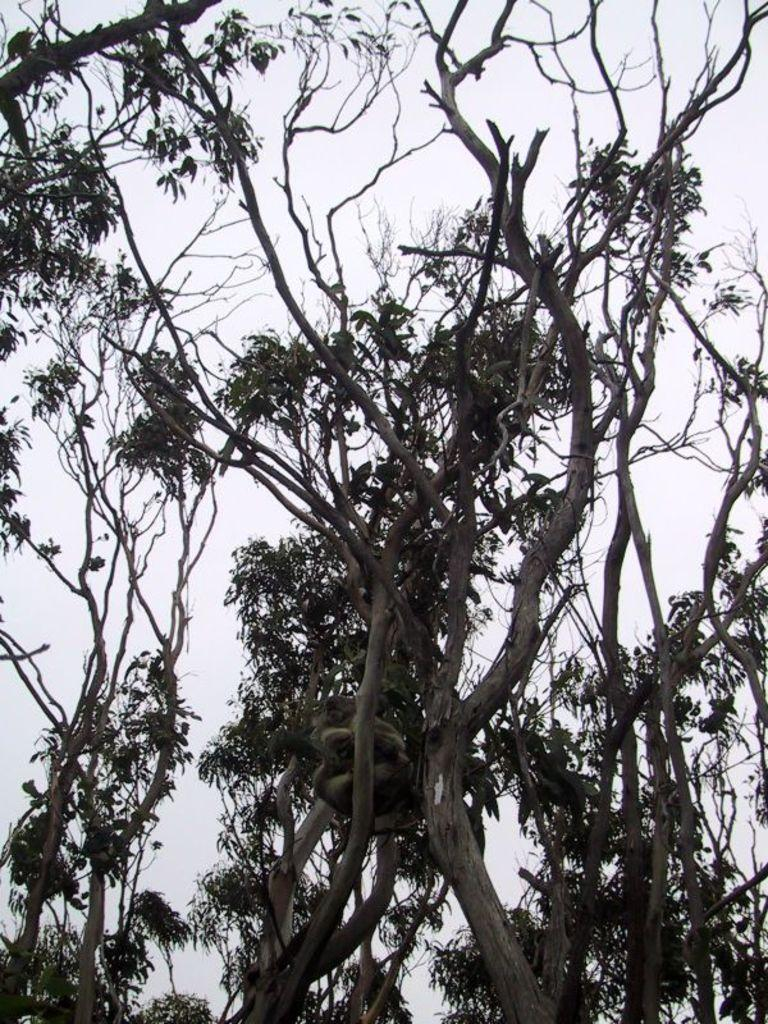What type of vegetation can be seen in the image? There are multiple trees in the image. What part of the natural environment is visible in the image? The sky is visible in the background of the image. What type of coat is the tree wearing in the image? Trees do not wear coats; they are plants. 